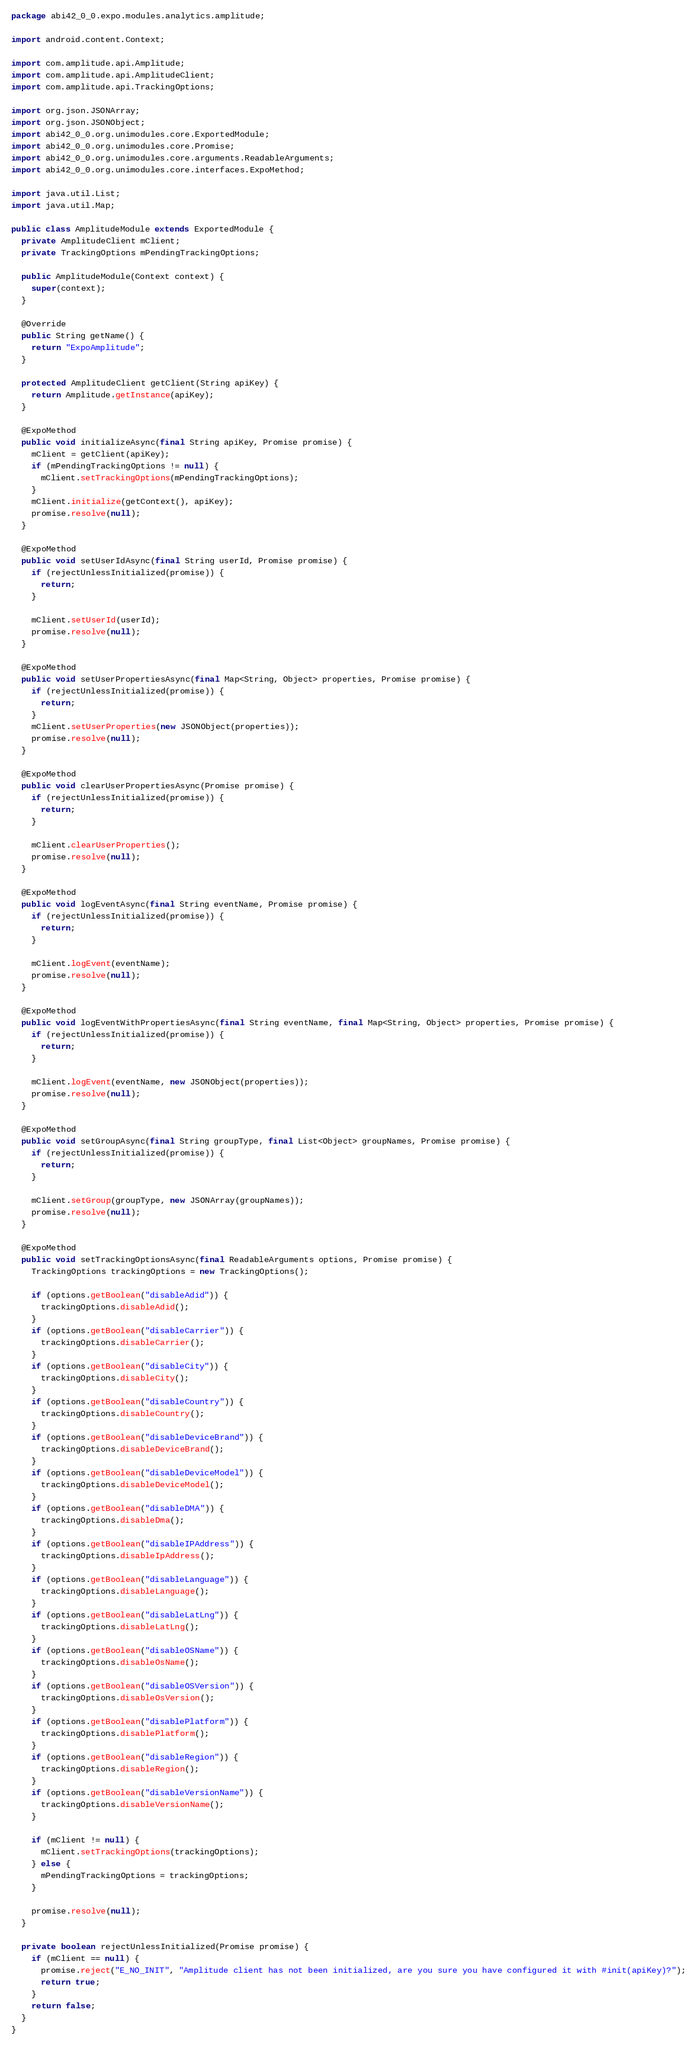Convert code to text. <code><loc_0><loc_0><loc_500><loc_500><_Java_>package abi42_0_0.expo.modules.analytics.amplitude;

import android.content.Context;

import com.amplitude.api.Amplitude;
import com.amplitude.api.AmplitudeClient;
import com.amplitude.api.TrackingOptions;

import org.json.JSONArray;
import org.json.JSONObject;
import abi42_0_0.org.unimodules.core.ExportedModule;
import abi42_0_0.org.unimodules.core.Promise;
import abi42_0_0.org.unimodules.core.arguments.ReadableArguments;
import abi42_0_0.org.unimodules.core.interfaces.ExpoMethod;

import java.util.List;
import java.util.Map;

public class AmplitudeModule extends ExportedModule {
  private AmplitudeClient mClient;
  private TrackingOptions mPendingTrackingOptions;

  public AmplitudeModule(Context context) {
    super(context);
  }

  @Override
  public String getName() {
    return "ExpoAmplitude";
  }

  protected AmplitudeClient getClient(String apiKey) {
    return Amplitude.getInstance(apiKey);
  }

  @ExpoMethod
  public void initializeAsync(final String apiKey, Promise promise) {
    mClient = getClient(apiKey);
    if (mPendingTrackingOptions != null) {
      mClient.setTrackingOptions(mPendingTrackingOptions);
    }
    mClient.initialize(getContext(), apiKey);
    promise.resolve(null);
  }

  @ExpoMethod
  public void setUserIdAsync(final String userId, Promise promise) {
    if (rejectUnlessInitialized(promise)) {
      return;
    }

    mClient.setUserId(userId);
    promise.resolve(null);
  }

  @ExpoMethod
  public void setUserPropertiesAsync(final Map<String, Object> properties, Promise promise) {
    if (rejectUnlessInitialized(promise)) {
      return;
    }
    mClient.setUserProperties(new JSONObject(properties));
    promise.resolve(null);
  }

  @ExpoMethod
  public void clearUserPropertiesAsync(Promise promise) {
    if (rejectUnlessInitialized(promise)) {
      return;
    }

    mClient.clearUserProperties();
    promise.resolve(null);
  }

  @ExpoMethod
  public void logEventAsync(final String eventName, Promise promise) {
    if (rejectUnlessInitialized(promise)) {
      return;
    }

    mClient.logEvent(eventName);
    promise.resolve(null);
  }

  @ExpoMethod
  public void logEventWithPropertiesAsync(final String eventName, final Map<String, Object> properties, Promise promise) {
    if (rejectUnlessInitialized(promise)) {
      return;
    }

    mClient.logEvent(eventName, new JSONObject(properties));
    promise.resolve(null);
  }

  @ExpoMethod
  public void setGroupAsync(final String groupType, final List<Object> groupNames, Promise promise) {
    if (rejectUnlessInitialized(promise)) {
      return;
    }

    mClient.setGroup(groupType, new JSONArray(groupNames));
    promise.resolve(null);
  }

  @ExpoMethod
  public void setTrackingOptionsAsync(final ReadableArguments options, Promise promise) {
    TrackingOptions trackingOptions = new TrackingOptions();

    if (options.getBoolean("disableAdid")) {
      trackingOptions.disableAdid();
    }
    if (options.getBoolean("disableCarrier")) {
      trackingOptions.disableCarrier();
    }
    if (options.getBoolean("disableCity")) {
      trackingOptions.disableCity();
    }
    if (options.getBoolean("disableCountry")) {
      trackingOptions.disableCountry();
    }
    if (options.getBoolean("disableDeviceBrand")) {
      trackingOptions.disableDeviceBrand();
    }
    if (options.getBoolean("disableDeviceModel")) {
      trackingOptions.disableDeviceModel();
    }
    if (options.getBoolean("disableDMA")) {
      trackingOptions.disableDma();
    }
    if (options.getBoolean("disableIPAddress")) {
      trackingOptions.disableIpAddress();
    }
    if (options.getBoolean("disableLanguage")) {
      trackingOptions.disableLanguage();
    }
    if (options.getBoolean("disableLatLng")) {
      trackingOptions.disableLatLng();
    }
    if (options.getBoolean("disableOSName")) {
      trackingOptions.disableOsName();
    }
    if (options.getBoolean("disableOSVersion")) {
      trackingOptions.disableOsVersion();
    }
    if (options.getBoolean("disablePlatform")) {
      trackingOptions.disablePlatform();
    }
    if (options.getBoolean("disableRegion")) {
      trackingOptions.disableRegion();
    }
    if (options.getBoolean("disableVersionName")) {
      trackingOptions.disableVersionName();
    }

    if (mClient != null) {
      mClient.setTrackingOptions(trackingOptions);
    } else {
      mPendingTrackingOptions = trackingOptions;
    }

    promise.resolve(null);
  }

  private boolean rejectUnlessInitialized(Promise promise) {
    if (mClient == null) {
      promise.reject("E_NO_INIT", "Amplitude client has not been initialized, are you sure you have configured it with #init(apiKey)?");
      return true;
    }
    return false;
  }
}
</code> 